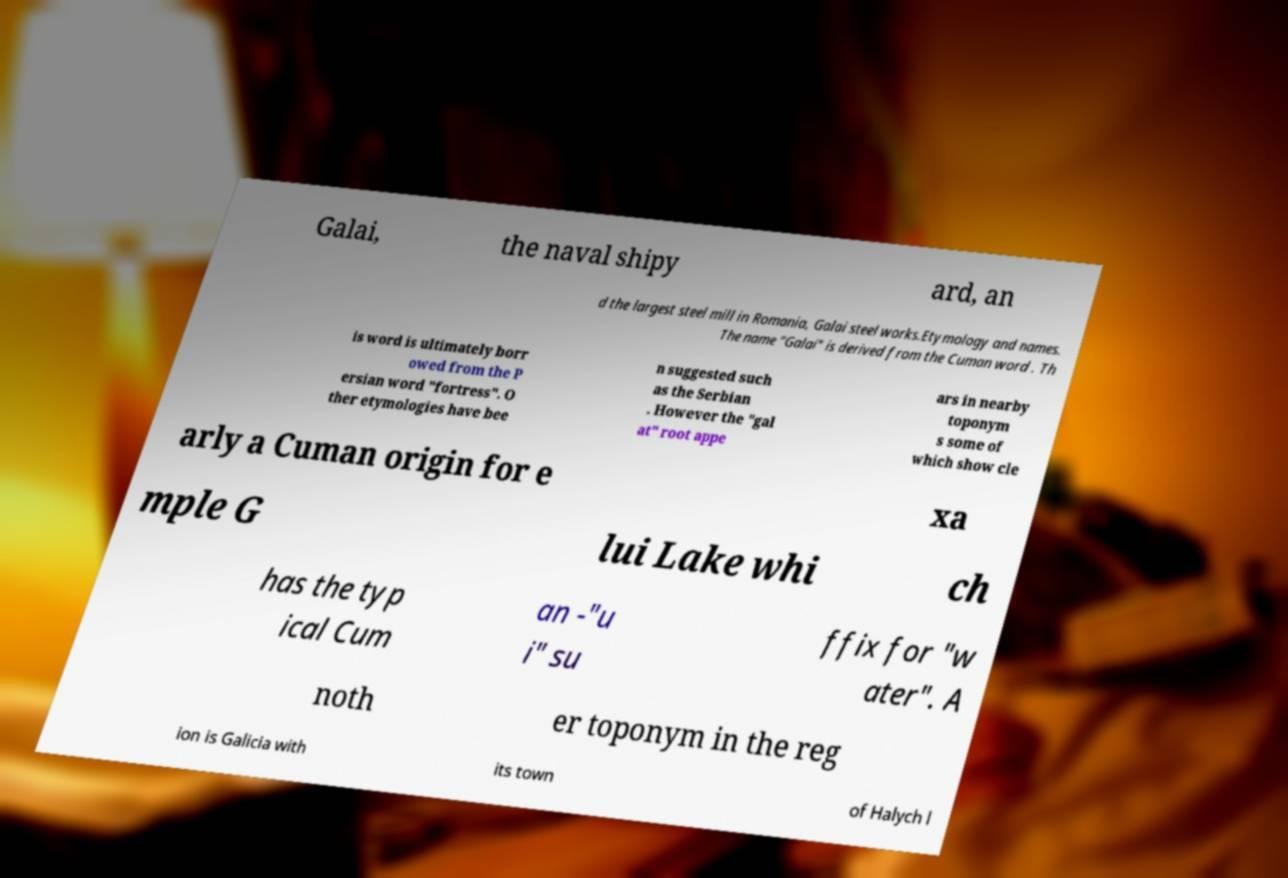There's text embedded in this image that I need extracted. Can you transcribe it verbatim? Galai, the naval shipy ard, an d the largest steel mill in Romania, Galai steel works.Etymology and names. The name "Galai" is derived from the Cuman word . Th is word is ultimately borr owed from the P ersian word "fortress". O ther etymologies have bee n suggested such as the Serbian . However the "gal at" root appe ars in nearby toponym s some of which show cle arly a Cuman origin for e xa mple G lui Lake whi ch has the typ ical Cum an -"u i" su ffix for "w ater". A noth er toponym in the reg ion is Galicia with its town of Halych l 